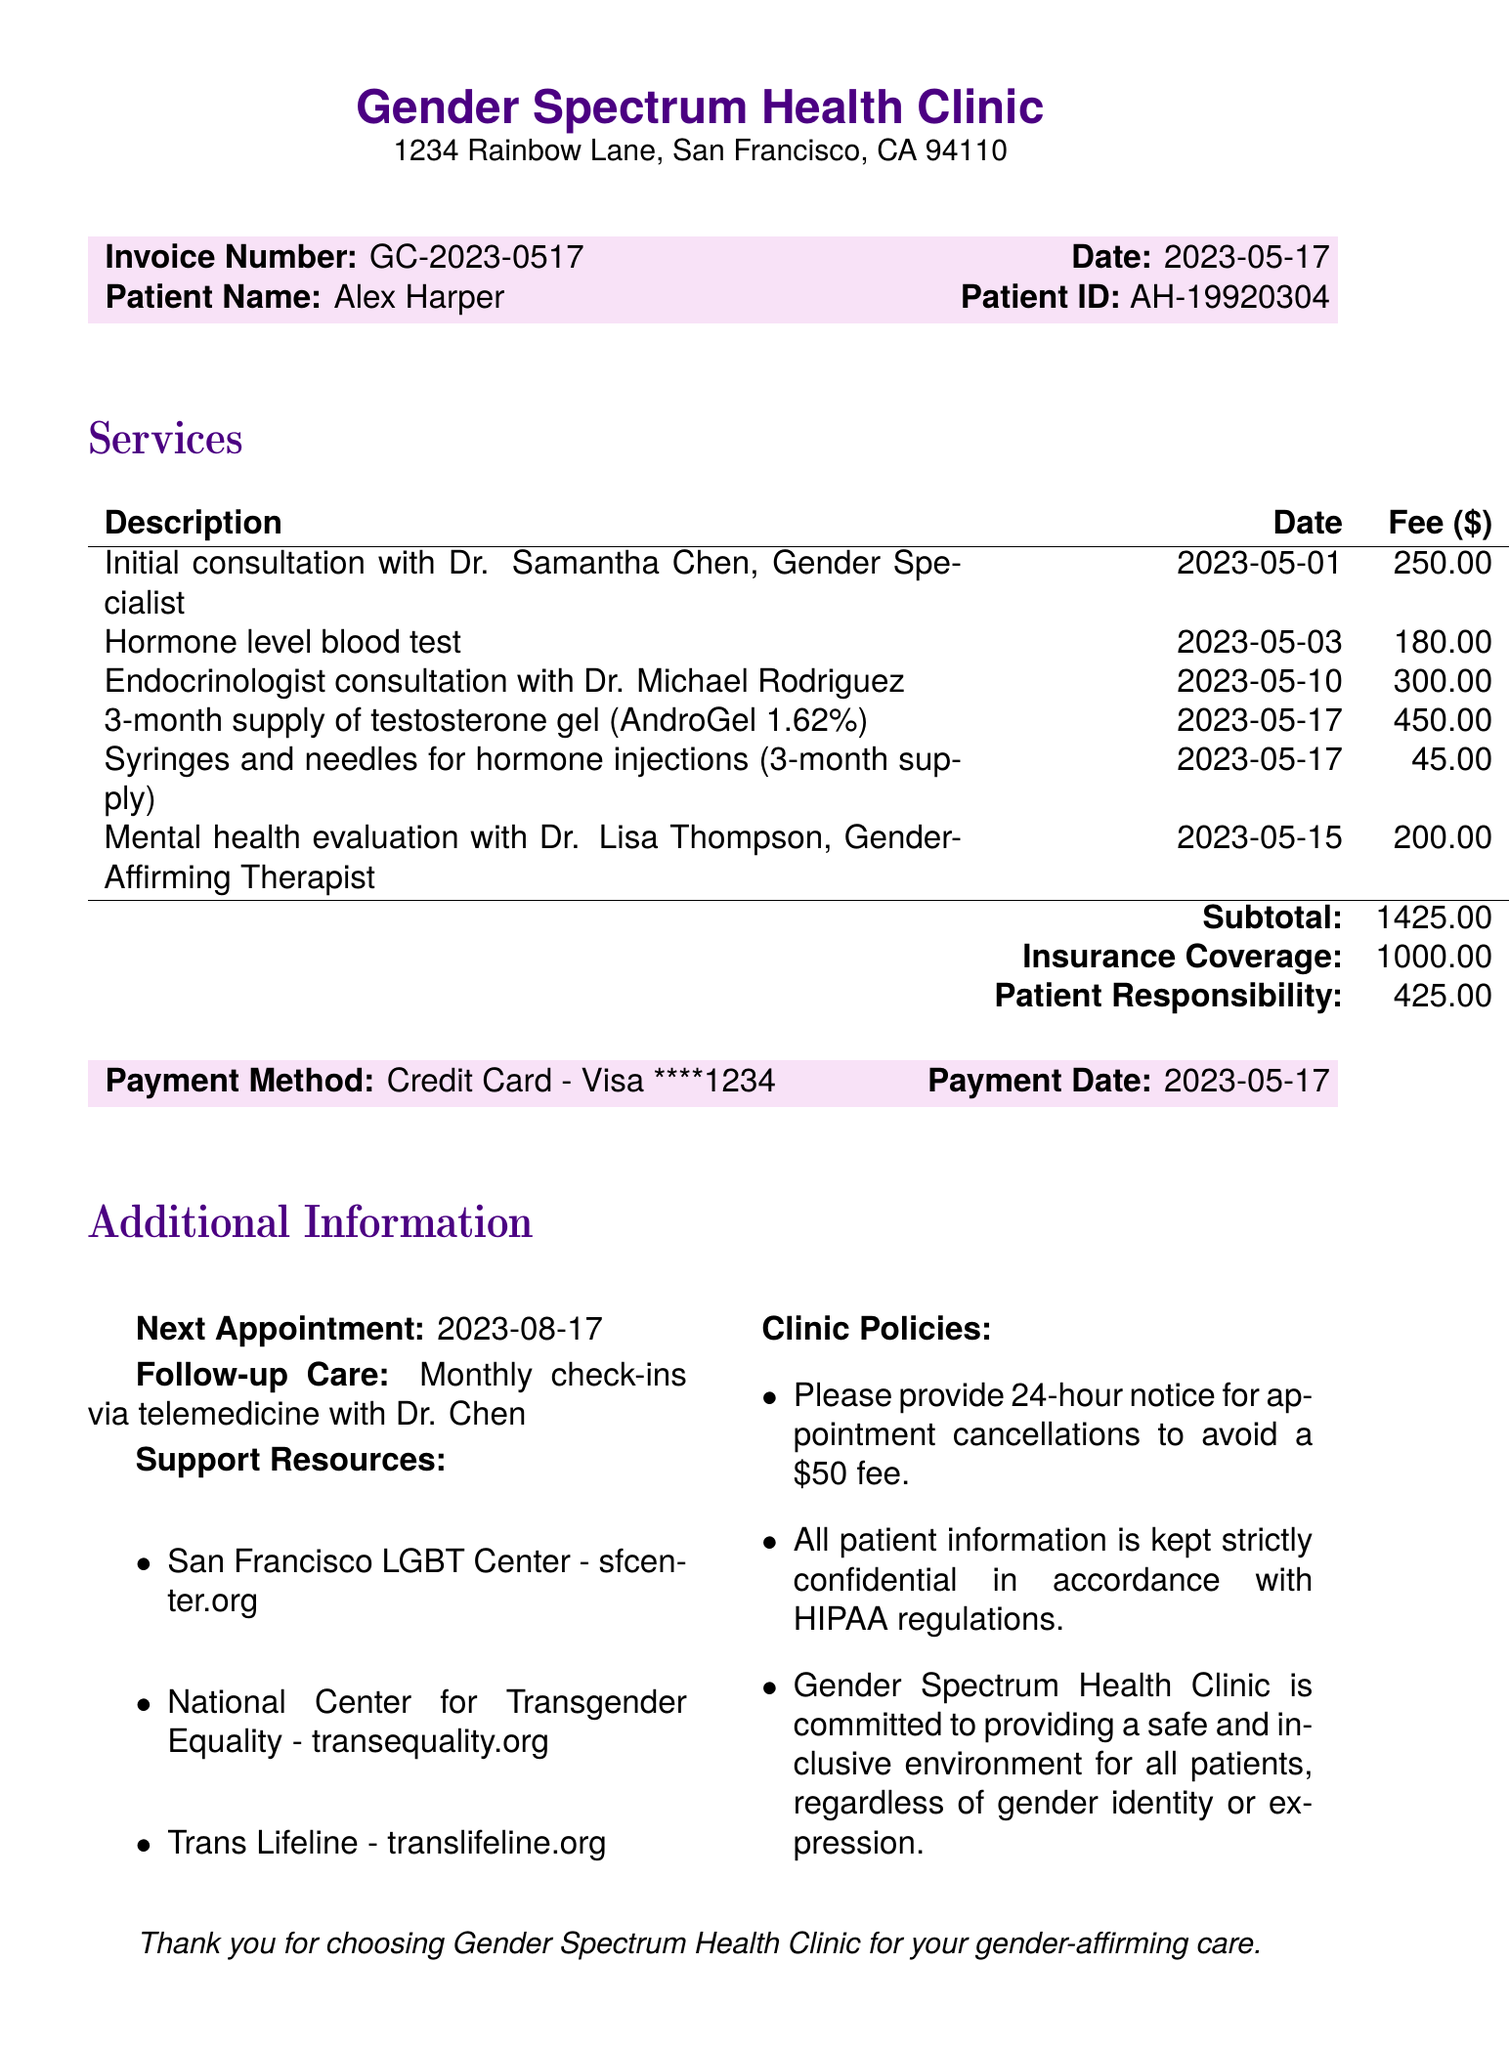What is the invoice number? The invoice number is listed at the top of the document for identification purposes.
Answer: GC-2023-0517 Who is the patient? The patient's name is provided in the invoice details section.
Answer: Alex Harper What is the total fee for the hormone level blood test? The fee for each service is detailed next to the service description, including the blood test.
Answer: 180.00 What is the patient responsibility amount? The document specifies the patient's responsibility after insurance coverage is applied.
Answer: 425.00 Who provided the initial consultation? The description of the initial consultation includes the name of the doctor who provided the service.
Answer: Dr. Samantha Chen When is the next appointment? The date for the next appointment is mentioned in the additional information section.
Answer: 2023-08-17 What is the cancellation policy? The document includes a specific statement about the cancellation policy in the clinic policies section.
Answer: 24-hour notice for appointment cancellations How much is the fee for the endocrinologist consultation? The details regarding service fees include specific amounts for each service, including endocrinologist consultation.
Answer: 300.00 What resources are provided for support? The document lists support resources available for patients, found in the additional information section.
Answer: San Francisco LGBT Center, National Center for Transgender Equality, Trans Lifeline 